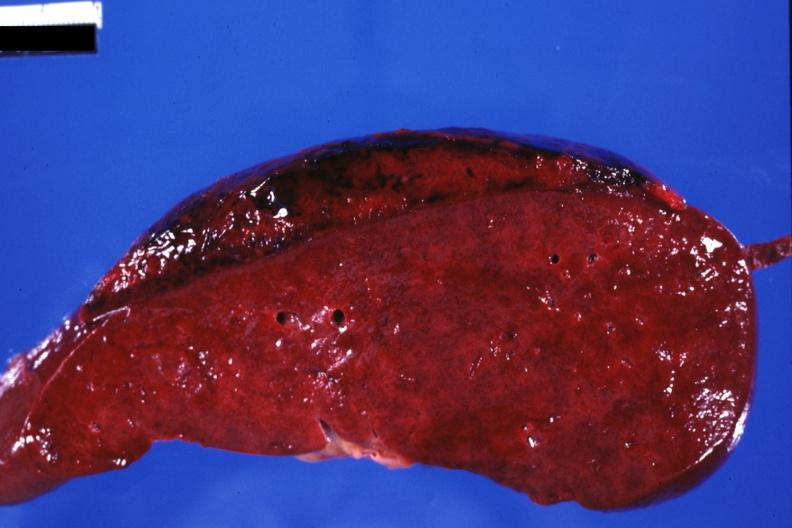s subcapsular hematoma present?
Answer the question using a single word or phrase. Yes 